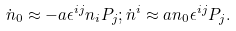Convert formula to latex. <formula><loc_0><loc_0><loc_500><loc_500>\dot { n } _ { 0 } \approx - a \epsilon ^ { i j } n _ { i } P _ { j } ; \dot { n } ^ { i } \approx a n _ { 0 } \epsilon ^ { i j } P _ { j } .</formula> 